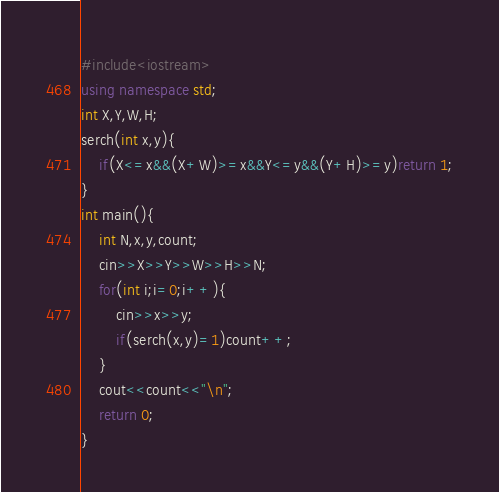<code> <loc_0><loc_0><loc_500><loc_500><_C++_>#include<iostream>
using namespace std;
int X,Y,W,H;
serch(int x,y){
	if(X<=x&&(X+W)>=x&&Y<=y&&(Y+H)>=y)return 1;
}	
int main(){
	int N,x,y,count;
	cin>>X>>Y>>W>>H>>N;
	for(int i;i=0;i++){
		cin>>x>>y;
		if(serch(x,y)=1)count++;
	}
	cout<<count<<"\n";
	return 0;
}</code> 